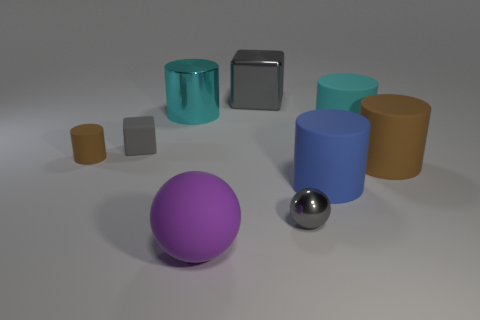Subtract all yellow cylinders. Subtract all blue balls. How many cylinders are left? 5 Subtract all spheres. How many objects are left? 7 Add 7 cyan shiny objects. How many cyan shiny objects are left? 8 Add 7 small cubes. How many small cubes exist? 8 Subtract 1 blue cylinders. How many objects are left? 8 Subtract all brown cylinders. Subtract all big rubber objects. How many objects are left? 3 